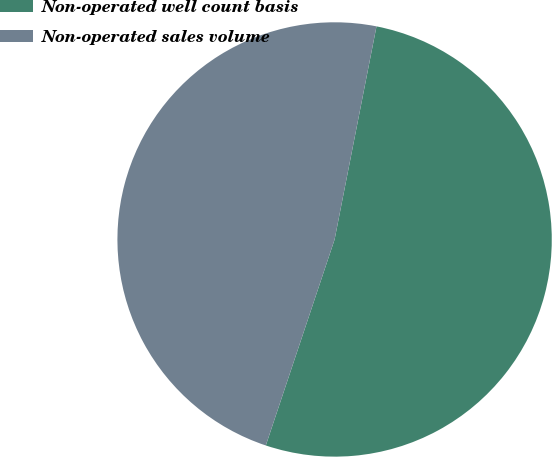<chart> <loc_0><loc_0><loc_500><loc_500><pie_chart><fcel>Non-operated well count basis<fcel>Non-operated sales volume<nl><fcel>52.04%<fcel>47.96%<nl></chart> 